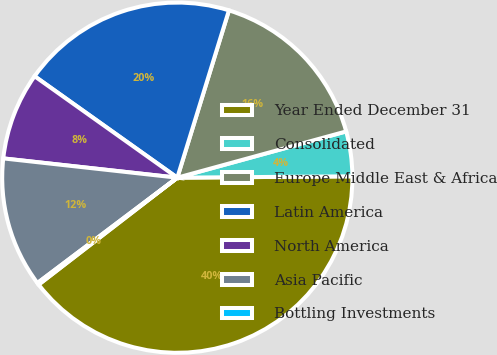Convert chart to OTSL. <chart><loc_0><loc_0><loc_500><loc_500><pie_chart><fcel>Year Ended December 31<fcel>Consolidated<fcel>Europe Middle East & Africa<fcel>Latin America<fcel>North America<fcel>Asia Pacific<fcel>Bottling Investments<nl><fcel>39.67%<fcel>4.13%<fcel>15.98%<fcel>19.93%<fcel>8.08%<fcel>12.03%<fcel>0.18%<nl></chart> 